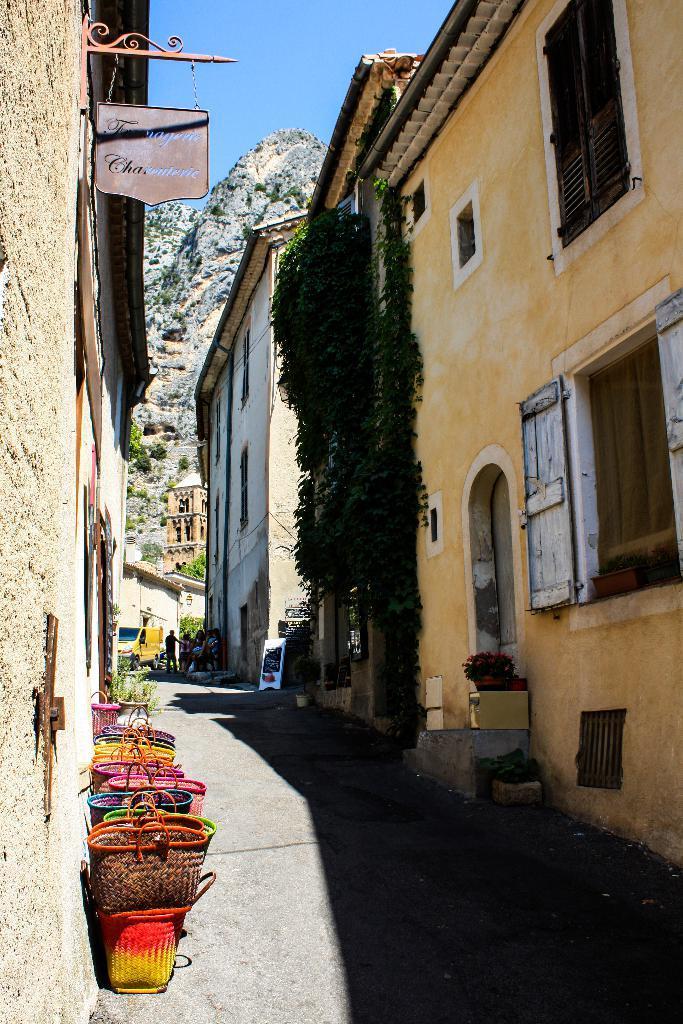Please provide a concise description of this image. In this image I can see the buildings. On the left side I can see the baskets on the road. I can see a board with some text written on it. In the background, I can see the hills and the sky. 